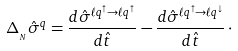Convert formula to latex. <formula><loc_0><loc_0><loc_500><loc_500>\Delta _ { _ { N } } \hat { \sigma } ^ { q } = { \frac { d \hat { \sigma } ^ { \ell q ^ { \uparrow } \to \ell q ^ { \uparrow } } } { d \hat { t } } } - { \frac { d \hat { \sigma } ^ { \ell q ^ { \uparrow } \to \ell q ^ { \downarrow } } } { d \hat { t } } } \, \cdot</formula> 